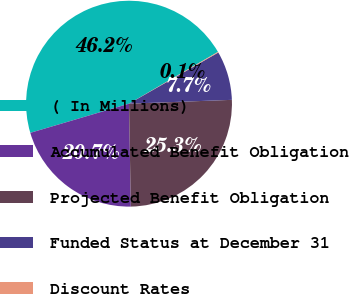Convert chart to OTSL. <chart><loc_0><loc_0><loc_500><loc_500><pie_chart><fcel>( In Millions)<fcel>Accumulated Benefit Obligation<fcel>Projected Benefit Obligation<fcel>Funded Status at December 31<fcel>Discount Rates<nl><fcel>46.18%<fcel>20.71%<fcel>25.31%<fcel>7.69%<fcel>0.11%<nl></chart> 